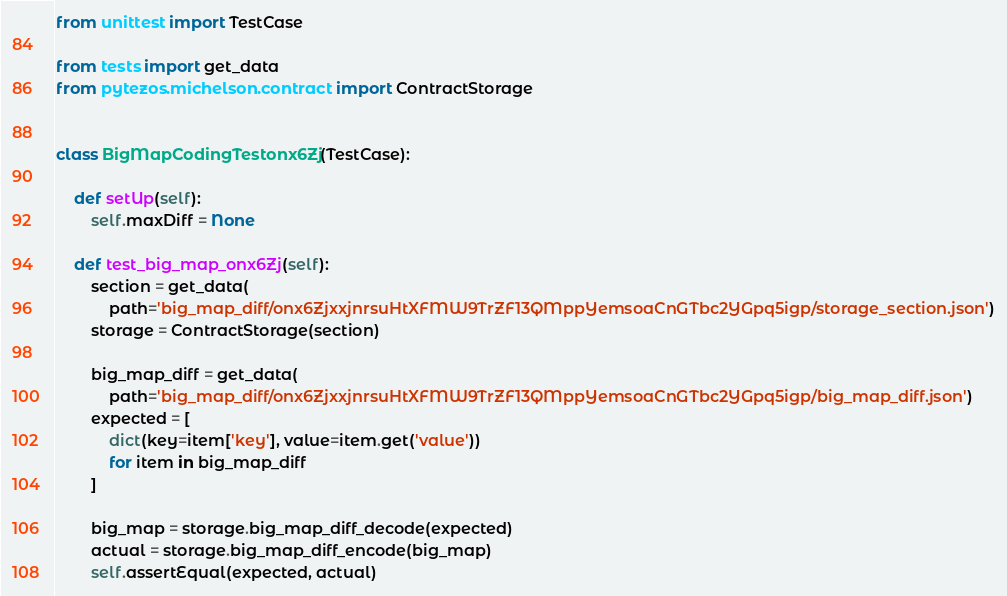<code> <loc_0><loc_0><loc_500><loc_500><_Python_>from unittest import TestCase

from tests import get_data
from pytezos.michelson.contract import ContractStorage


class BigMapCodingTestonx6Zj(TestCase):

    def setUp(self):
        self.maxDiff = None

    def test_big_map_onx6Zj(self):    
        section = get_data(
            path='big_map_diff/onx6ZjxxjnrsuHtXFMW9TrZF13QMppYemsoaCnGTbc2YGpq5igp/storage_section.json')
        storage = ContractStorage(section)
            
        big_map_diff = get_data(
            path='big_map_diff/onx6ZjxxjnrsuHtXFMW9TrZF13QMppYemsoaCnGTbc2YGpq5igp/big_map_diff.json')
        expected = [
            dict(key=item['key'], value=item.get('value'))
            for item in big_map_diff
        ]
        
        big_map = storage.big_map_diff_decode(expected)
        actual = storage.big_map_diff_encode(big_map)
        self.assertEqual(expected, actual)
</code> 